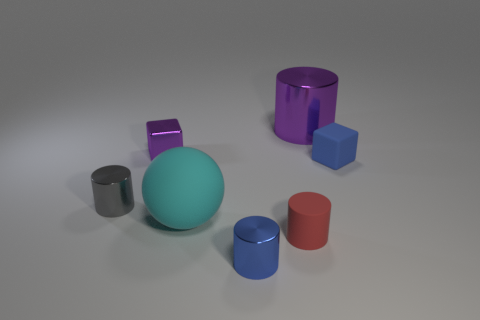Subtract all blue shiny cylinders. How many cylinders are left? 3 Subtract all cyan cylinders. Subtract all green balls. How many cylinders are left? 4 Add 3 small blue metallic things. How many objects exist? 10 Subtract all cubes. How many objects are left? 5 Subtract all small metal blocks. Subtract all tiny gray metallic objects. How many objects are left? 5 Add 4 spheres. How many spheres are left? 5 Add 1 tiny shiny cylinders. How many tiny shiny cylinders exist? 3 Subtract 0 blue spheres. How many objects are left? 7 